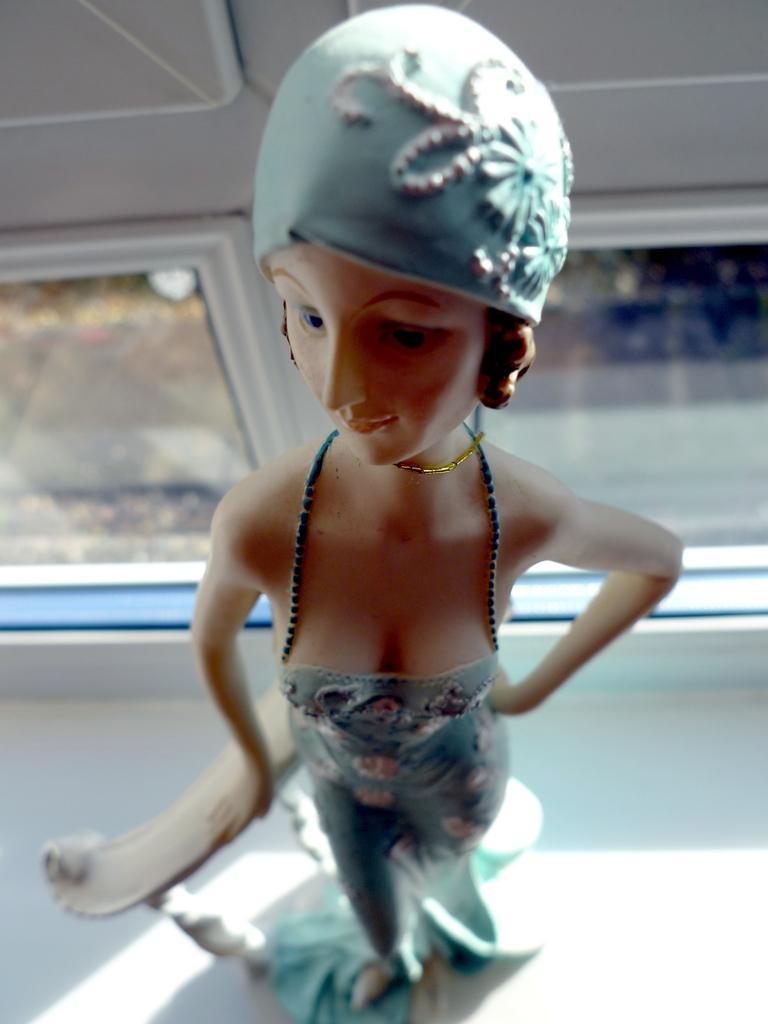How would you summarize this image in a sentence or two? In this picture there is a doll. The background is blurred. 